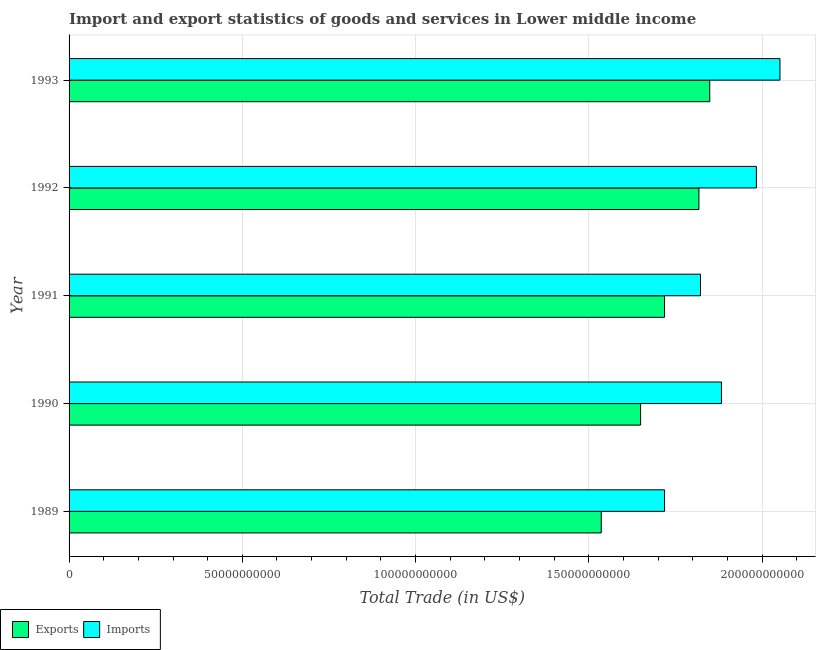How many groups of bars are there?
Offer a very short reply. 5. How many bars are there on the 2nd tick from the top?
Keep it short and to the point. 2. What is the label of the 4th group of bars from the top?
Give a very brief answer. 1990. In how many cases, is the number of bars for a given year not equal to the number of legend labels?
Provide a short and direct response. 0. What is the imports of goods and services in 1990?
Offer a very short reply. 1.88e+11. Across all years, what is the maximum imports of goods and services?
Provide a short and direct response. 2.05e+11. Across all years, what is the minimum imports of goods and services?
Give a very brief answer. 1.72e+11. What is the total imports of goods and services in the graph?
Your answer should be very brief. 9.46e+11. What is the difference between the export of goods and services in 1991 and that in 1992?
Make the answer very short. -9.92e+09. What is the difference between the imports of goods and services in 1991 and the export of goods and services in 1992?
Your answer should be very brief. 4.54e+08. What is the average export of goods and services per year?
Keep it short and to the point. 1.71e+11. In the year 1993, what is the difference between the imports of goods and services and export of goods and services?
Ensure brevity in your answer.  2.03e+1. What is the ratio of the export of goods and services in 1989 to that in 1992?
Your answer should be very brief. 0.84. Is the export of goods and services in 1990 less than that in 1993?
Provide a short and direct response. Yes. What is the difference between the highest and the second highest export of goods and services?
Offer a terse response. 3.12e+09. What is the difference between the highest and the lowest export of goods and services?
Offer a very short reply. 3.13e+1. In how many years, is the imports of goods and services greater than the average imports of goods and services taken over all years?
Give a very brief answer. 2. Is the sum of the export of goods and services in 1989 and 1993 greater than the maximum imports of goods and services across all years?
Offer a terse response. Yes. What does the 2nd bar from the top in 1993 represents?
Ensure brevity in your answer.  Exports. What does the 1st bar from the bottom in 1991 represents?
Offer a very short reply. Exports. How many bars are there?
Offer a terse response. 10. Are the values on the major ticks of X-axis written in scientific E-notation?
Your answer should be compact. No. Where does the legend appear in the graph?
Your response must be concise. Bottom left. How are the legend labels stacked?
Your response must be concise. Horizontal. What is the title of the graph?
Your answer should be compact. Import and export statistics of goods and services in Lower middle income. Does "Private credit bureau" appear as one of the legend labels in the graph?
Your answer should be very brief. No. What is the label or title of the X-axis?
Ensure brevity in your answer.  Total Trade (in US$). What is the label or title of the Y-axis?
Your response must be concise. Year. What is the Total Trade (in US$) in Exports in 1989?
Your answer should be compact. 1.54e+11. What is the Total Trade (in US$) in Imports in 1989?
Provide a short and direct response. 1.72e+11. What is the Total Trade (in US$) of Exports in 1990?
Provide a succinct answer. 1.65e+11. What is the Total Trade (in US$) of Imports in 1990?
Offer a very short reply. 1.88e+11. What is the Total Trade (in US$) in Exports in 1991?
Your answer should be very brief. 1.72e+11. What is the Total Trade (in US$) of Imports in 1991?
Offer a very short reply. 1.82e+11. What is the Total Trade (in US$) in Exports in 1992?
Your response must be concise. 1.82e+11. What is the Total Trade (in US$) of Imports in 1992?
Provide a succinct answer. 1.98e+11. What is the Total Trade (in US$) of Exports in 1993?
Give a very brief answer. 1.85e+11. What is the Total Trade (in US$) of Imports in 1993?
Your response must be concise. 2.05e+11. Across all years, what is the maximum Total Trade (in US$) in Exports?
Provide a short and direct response. 1.85e+11. Across all years, what is the maximum Total Trade (in US$) of Imports?
Make the answer very short. 2.05e+11. Across all years, what is the minimum Total Trade (in US$) in Exports?
Offer a terse response. 1.54e+11. Across all years, what is the minimum Total Trade (in US$) in Imports?
Your answer should be compact. 1.72e+11. What is the total Total Trade (in US$) of Exports in the graph?
Give a very brief answer. 8.57e+11. What is the total Total Trade (in US$) in Imports in the graph?
Make the answer very short. 9.46e+11. What is the difference between the Total Trade (in US$) of Exports in 1989 and that in 1990?
Offer a very short reply. -1.14e+1. What is the difference between the Total Trade (in US$) of Imports in 1989 and that in 1990?
Provide a short and direct response. -1.64e+1. What is the difference between the Total Trade (in US$) in Exports in 1989 and that in 1991?
Ensure brevity in your answer.  -1.83e+1. What is the difference between the Total Trade (in US$) in Imports in 1989 and that in 1991?
Your answer should be compact. -1.04e+1. What is the difference between the Total Trade (in US$) in Exports in 1989 and that in 1992?
Offer a terse response. -2.82e+1. What is the difference between the Total Trade (in US$) in Imports in 1989 and that in 1992?
Give a very brief answer. -2.65e+1. What is the difference between the Total Trade (in US$) of Exports in 1989 and that in 1993?
Your answer should be very brief. -3.13e+1. What is the difference between the Total Trade (in US$) in Imports in 1989 and that in 1993?
Offer a terse response. -3.33e+1. What is the difference between the Total Trade (in US$) in Exports in 1990 and that in 1991?
Your answer should be very brief. -6.91e+09. What is the difference between the Total Trade (in US$) in Imports in 1990 and that in 1991?
Your response must be concise. 6.05e+09. What is the difference between the Total Trade (in US$) in Exports in 1990 and that in 1992?
Make the answer very short. -1.68e+1. What is the difference between the Total Trade (in US$) in Imports in 1990 and that in 1992?
Provide a short and direct response. -1.01e+1. What is the difference between the Total Trade (in US$) of Exports in 1990 and that in 1993?
Your answer should be compact. -2.00e+1. What is the difference between the Total Trade (in US$) of Imports in 1990 and that in 1993?
Make the answer very short. -1.69e+1. What is the difference between the Total Trade (in US$) of Exports in 1991 and that in 1992?
Your answer should be compact. -9.92e+09. What is the difference between the Total Trade (in US$) in Imports in 1991 and that in 1992?
Give a very brief answer. -1.61e+1. What is the difference between the Total Trade (in US$) of Exports in 1991 and that in 1993?
Your answer should be very brief. -1.30e+1. What is the difference between the Total Trade (in US$) in Imports in 1991 and that in 1993?
Your response must be concise. -2.29e+1. What is the difference between the Total Trade (in US$) of Exports in 1992 and that in 1993?
Provide a short and direct response. -3.12e+09. What is the difference between the Total Trade (in US$) of Imports in 1992 and that in 1993?
Your response must be concise. -6.80e+09. What is the difference between the Total Trade (in US$) of Exports in 1989 and the Total Trade (in US$) of Imports in 1990?
Give a very brief answer. -3.47e+1. What is the difference between the Total Trade (in US$) of Exports in 1989 and the Total Trade (in US$) of Imports in 1991?
Ensure brevity in your answer.  -2.86e+1. What is the difference between the Total Trade (in US$) in Exports in 1989 and the Total Trade (in US$) in Imports in 1992?
Your response must be concise. -4.48e+1. What is the difference between the Total Trade (in US$) of Exports in 1989 and the Total Trade (in US$) of Imports in 1993?
Give a very brief answer. -5.16e+1. What is the difference between the Total Trade (in US$) of Exports in 1990 and the Total Trade (in US$) of Imports in 1991?
Offer a terse response. -1.73e+1. What is the difference between the Total Trade (in US$) of Exports in 1990 and the Total Trade (in US$) of Imports in 1992?
Keep it short and to the point. -3.34e+1. What is the difference between the Total Trade (in US$) in Exports in 1990 and the Total Trade (in US$) in Imports in 1993?
Offer a very short reply. -4.02e+1. What is the difference between the Total Trade (in US$) of Exports in 1991 and the Total Trade (in US$) of Imports in 1992?
Offer a terse response. -2.65e+1. What is the difference between the Total Trade (in US$) in Exports in 1991 and the Total Trade (in US$) in Imports in 1993?
Ensure brevity in your answer.  -3.33e+1. What is the difference between the Total Trade (in US$) of Exports in 1992 and the Total Trade (in US$) of Imports in 1993?
Your answer should be very brief. -2.34e+1. What is the average Total Trade (in US$) in Exports per year?
Give a very brief answer. 1.71e+11. What is the average Total Trade (in US$) in Imports per year?
Provide a short and direct response. 1.89e+11. In the year 1989, what is the difference between the Total Trade (in US$) of Exports and Total Trade (in US$) of Imports?
Provide a succinct answer. -1.83e+1. In the year 1990, what is the difference between the Total Trade (in US$) in Exports and Total Trade (in US$) in Imports?
Keep it short and to the point. -2.33e+1. In the year 1991, what is the difference between the Total Trade (in US$) in Exports and Total Trade (in US$) in Imports?
Give a very brief answer. -1.04e+1. In the year 1992, what is the difference between the Total Trade (in US$) of Exports and Total Trade (in US$) of Imports?
Keep it short and to the point. -1.66e+1. In the year 1993, what is the difference between the Total Trade (in US$) of Exports and Total Trade (in US$) of Imports?
Your answer should be compact. -2.03e+1. What is the ratio of the Total Trade (in US$) of Exports in 1989 to that in 1990?
Give a very brief answer. 0.93. What is the ratio of the Total Trade (in US$) in Imports in 1989 to that in 1990?
Ensure brevity in your answer.  0.91. What is the ratio of the Total Trade (in US$) of Exports in 1989 to that in 1991?
Provide a short and direct response. 0.89. What is the ratio of the Total Trade (in US$) of Imports in 1989 to that in 1991?
Provide a short and direct response. 0.94. What is the ratio of the Total Trade (in US$) of Exports in 1989 to that in 1992?
Ensure brevity in your answer.  0.84. What is the ratio of the Total Trade (in US$) of Imports in 1989 to that in 1992?
Offer a terse response. 0.87. What is the ratio of the Total Trade (in US$) of Exports in 1989 to that in 1993?
Your answer should be compact. 0.83. What is the ratio of the Total Trade (in US$) of Imports in 1989 to that in 1993?
Your answer should be very brief. 0.84. What is the ratio of the Total Trade (in US$) in Exports in 1990 to that in 1991?
Your response must be concise. 0.96. What is the ratio of the Total Trade (in US$) in Imports in 1990 to that in 1991?
Make the answer very short. 1.03. What is the ratio of the Total Trade (in US$) of Exports in 1990 to that in 1992?
Offer a very short reply. 0.91. What is the ratio of the Total Trade (in US$) of Imports in 1990 to that in 1992?
Offer a very short reply. 0.95. What is the ratio of the Total Trade (in US$) of Exports in 1990 to that in 1993?
Provide a short and direct response. 0.89. What is the ratio of the Total Trade (in US$) of Imports in 1990 to that in 1993?
Your answer should be compact. 0.92. What is the ratio of the Total Trade (in US$) in Exports in 1991 to that in 1992?
Make the answer very short. 0.95. What is the ratio of the Total Trade (in US$) in Imports in 1991 to that in 1992?
Your response must be concise. 0.92. What is the ratio of the Total Trade (in US$) of Exports in 1991 to that in 1993?
Keep it short and to the point. 0.93. What is the ratio of the Total Trade (in US$) of Imports in 1991 to that in 1993?
Provide a short and direct response. 0.89. What is the ratio of the Total Trade (in US$) in Exports in 1992 to that in 1993?
Provide a short and direct response. 0.98. What is the ratio of the Total Trade (in US$) in Imports in 1992 to that in 1993?
Make the answer very short. 0.97. What is the difference between the highest and the second highest Total Trade (in US$) in Exports?
Make the answer very short. 3.12e+09. What is the difference between the highest and the second highest Total Trade (in US$) in Imports?
Offer a terse response. 6.80e+09. What is the difference between the highest and the lowest Total Trade (in US$) of Exports?
Ensure brevity in your answer.  3.13e+1. What is the difference between the highest and the lowest Total Trade (in US$) in Imports?
Your answer should be very brief. 3.33e+1. 